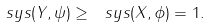<formula> <loc_0><loc_0><loc_500><loc_500>\ s y s ( Y , \psi ) \geq \ s y s ( X , \phi ) = 1 .</formula> 